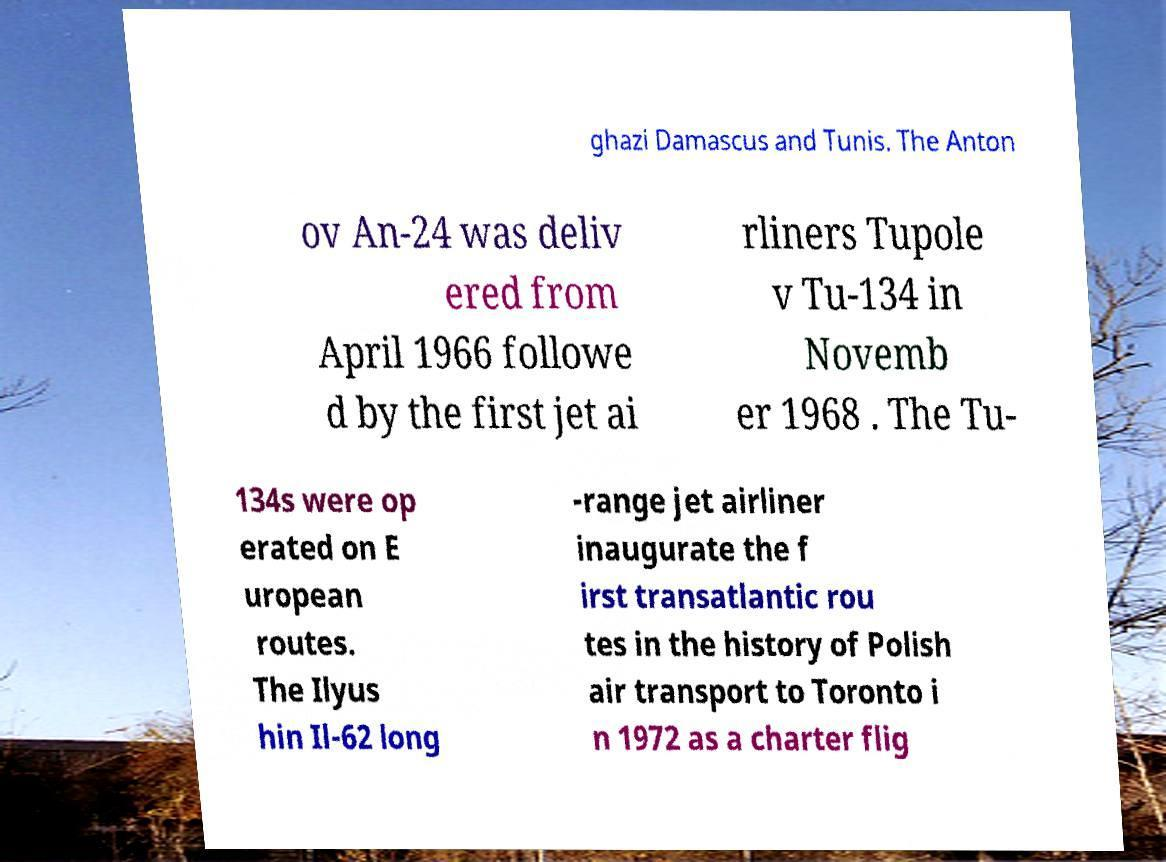Please read and relay the text visible in this image. What does it say? ghazi Damascus and Tunis. The Anton ov An-24 was deliv ered from April 1966 followe d by the first jet ai rliners Tupole v Tu-134 in Novemb er 1968 . The Tu- 134s were op erated on E uropean routes. The Ilyus hin Il-62 long -range jet airliner inaugurate the f irst transatlantic rou tes in the history of Polish air transport to Toronto i n 1972 as a charter flig 